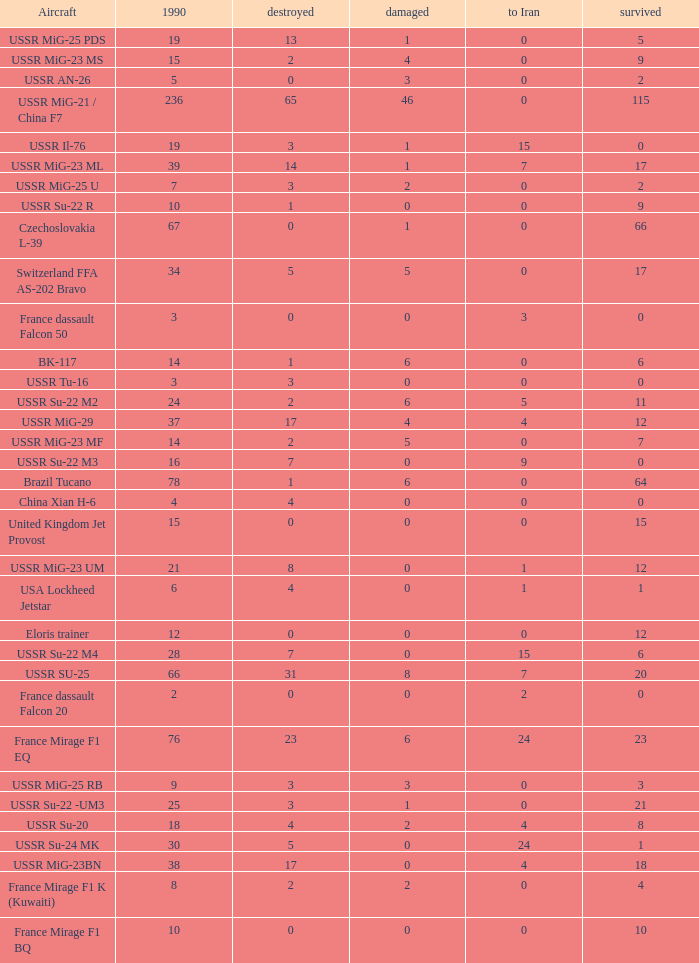If there were 14 in 1990 and 6 survived how many were destroyed? 1.0. 